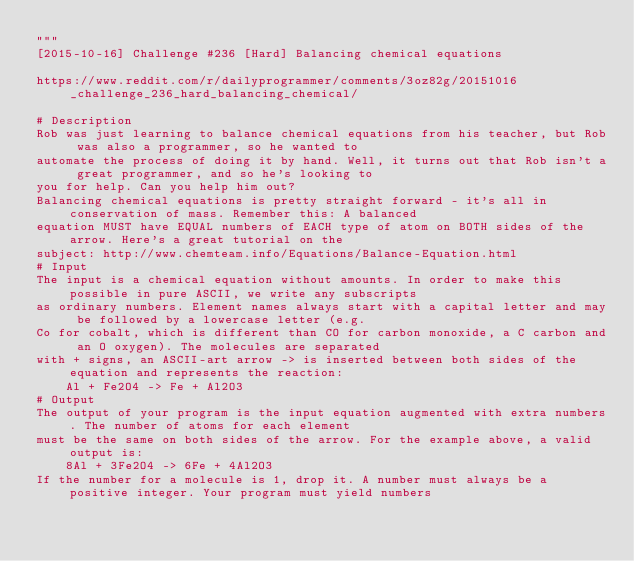Convert code to text. <code><loc_0><loc_0><loc_500><loc_500><_Python_>"""
[2015-10-16] Challenge #236 [Hard] Balancing chemical equations

https://www.reddit.com/r/dailyprogrammer/comments/3oz82g/20151016_challenge_236_hard_balancing_chemical/

# Description
Rob was just learning to balance chemical equations from his teacher, but Rob was also a programmer, so he wanted to
automate the process of doing it by hand. Well, it turns out that Rob isn't a great programmer, and so he's looking to
you for help. Can you help him out?
Balancing chemical equations is pretty straight forward - it's all in conservation of mass. Remember this: A balanced
equation MUST have EQUAL numbers of EACH type of atom on BOTH sides of the arrow. Here's a great tutorial on the
subject: http://www.chemteam.info/Equations/Balance-Equation.html 
# Input
The input is a chemical equation without amounts. In order to make this possible in pure ASCII, we write any subscripts
as ordinary numbers. Element names always start with a capital letter and may be followed by a lowercase letter (e.g.
Co for cobalt, which is different than CO for carbon monoxide, a C carbon and an O oxygen). The molecules are separated
with + signs, an ASCII-art arrow -> is inserted between both sides of the equation and represents the reaction:
    Al + Fe2O4 -> Fe + Al2O3
# Output
The output of your program is the input equation augmented with extra numbers. The number of atoms for each element
must be the same on both sides of the arrow. For the example above, a valid output is:
    8Al + 3Fe2O4 -> 6Fe + 4Al2O3  
If the number for a molecule is 1, drop it. A number must always be a positive integer. Your program must yield numbers</code> 